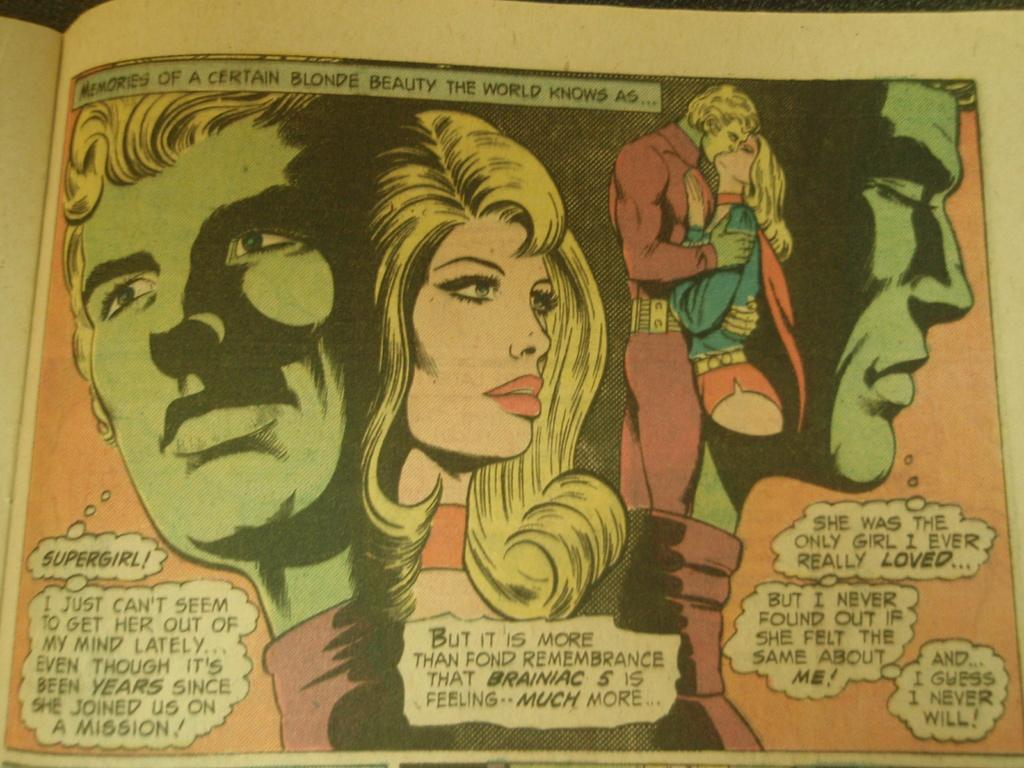<image>
Summarize the visual content of the image. The comic book is about Supergirl and Braniac 5. 